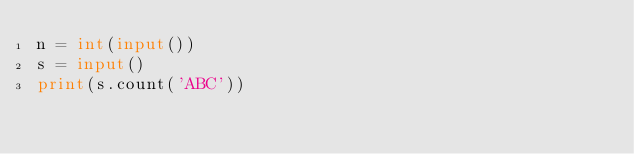Convert code to text. <code><loc_0><loc_0><loc_500><loc_500><_Python_>n = int(input())
s = input()
print(s.count('ABC'))</code> 